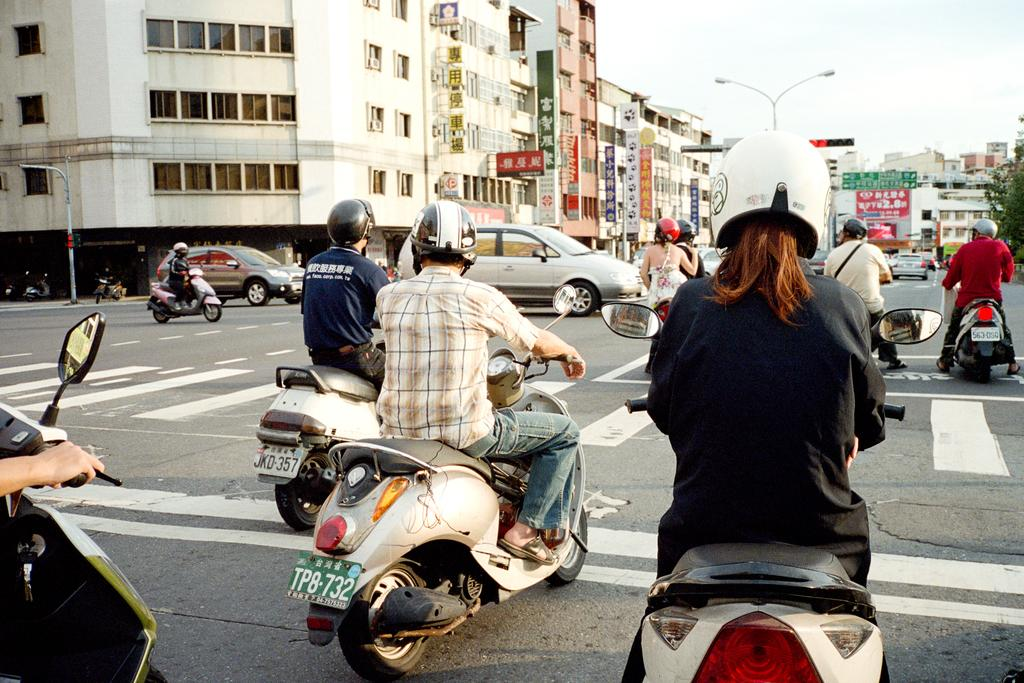What types of vehicles can be seen on the road in the image? There are vehicles on the road in the image, but the specific types are not mentioned. What are some people doing in the image? Some people are riding motorcycles in the image. What can be seen in the distance in the image? There are buildings with windows in the distance in the image. What type of cook is preparing apples in the image? There is no cook or apples present in the image. What kind of flesh can be seen on the people riding motorcycles in the image? There is no mention of flesh in the image; people riding motorcycles are clothed. 